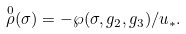Convert formula to latex. <formula><loc_0><loc_0><loc_500><loc_500>\overset { 0 } { \rho } ( \sigma ) = - { \wp } ( \sigma , g _ { 2 } , g _ { 3 } ) / u _ { * } .</formula> 